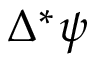<formula> <loc_0><loc_0><loc_500><loc_500>\Delta ^ { * } \psi</formula> 